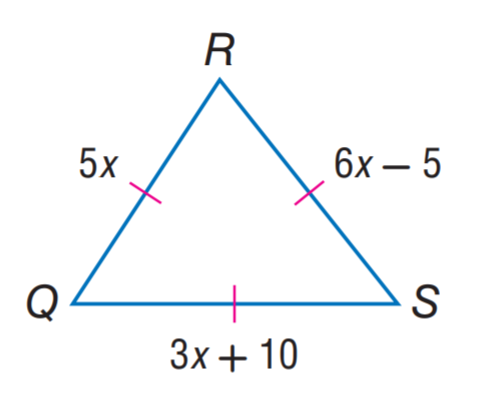Answer the mathemtical geometry problem and directly provide the correct option letter.
Question: Find R S.
Choices: A: 5 B: 15 C: 20 D: 25 D 